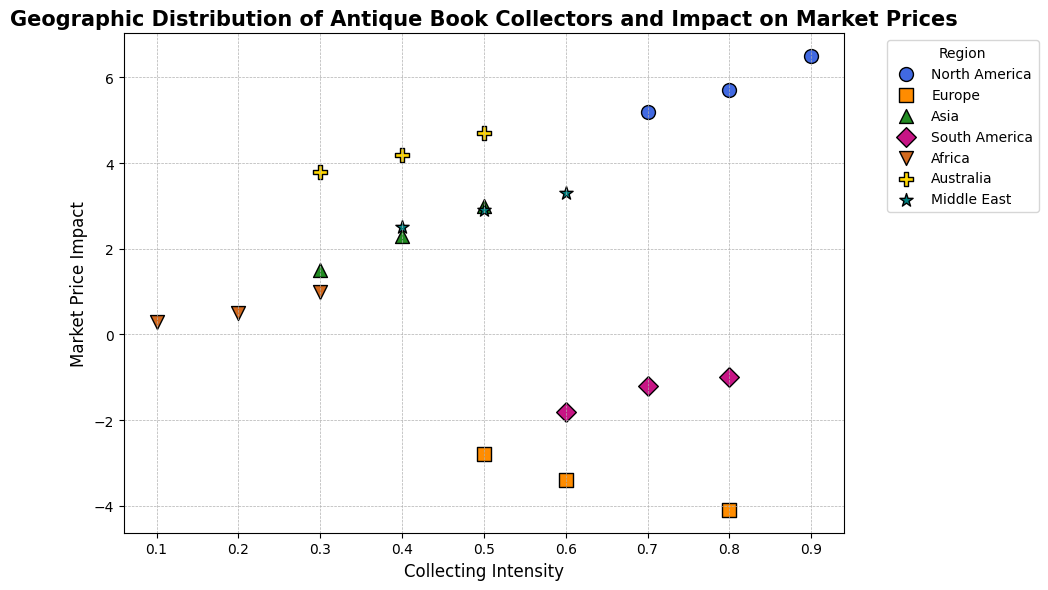What region has the highest collecting intensity? The region with the highest collecting intensity can be identified by looking for the region with the maximum value along the Collecting Intensity axis. North America shows a collecting intensity of 0.9, which is the highest.
Answer: North America Which region shows the highest positive impact on local market prices? To find this, look for the highest point along the Market Price Impact axis. North America has the highest positive impact on local market prices with a value of 6.5.
Answer: North America Which regions have a negative impact on local market prices? Regions with points below the zero line on the Market Price Impact axis have a negative impact. Europe and South America have all their data points with negative market price impacts.
Answer: Europe, South America Which region has the lowest collecting intensity and what is its market price impact? The lowest collecting intensity is found by looking at the minimum value on the Collecting Intensity axis. Africa has the lowest collecting intensity of 0.1 and its market price impact is 0.3.
Answer: Africa, 0.3 Compare the market price impact range in Asia and Australia. The market price impact in Asia ranges from 1.5 to 3.0, whereas in Australia it ranges from 3.8 to 4.7. Comparatively, Australia's market price impact range is higher than Asia's.
Answer: Australia's range is higher Which region has the most data points clustered near a collecting intensity of 0.5? By examining the scatter plot, Europe shows multiple data points closely clustered around a collecting intensity of 0.5, suggesting a concentration of collectors at this intensity level.
Answer: Europe Which regions have market price impacts that are always positive? Regions with all their points above the zero line on the Market Price Impact axis have consistently positive impacts. North America, Asia, Africa, Australia, and the Middle East fit this criterion.
Answer: North America, Asia, Africa, Australia, Middle East How does the collecting intensity compare between North America and South America? North America's collecting intensity ranges from 0.7 to 0.9, while South America's ranges from 0.6 to 0.8. North America generally has a higher collecting intensity than South America.
Answer: North America has a higher collecting intensity What is the average market price impact for Europe? The market price impacts for Europe are -3.4, -2.8, and -4.1. Calculating the average: (-3.4 + (-2.8) + (-4.1))/3 = -3.43.
Answer: -3.43 Which region shows the greatest variation in market price impact? The greatest variation can be seen by identifying the widest range in market price impacts. Europe varies from -4.1 to -2.8, showing a significant negative impact range.
Answer: Europe 